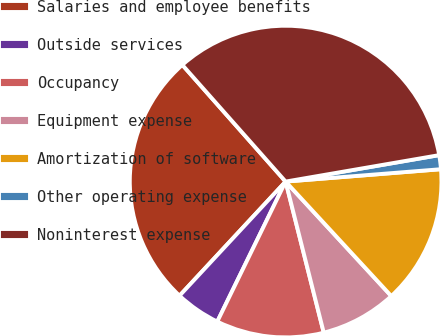Convert chart to OTSL. <chart><loc_0><loc_0><loc_500><loc_500><pie_chart><fcel>Salaries and employee benefits<fcel>Outside services<fcel>Occupancy<fcel>Equipment expense<fcel>Amortization of software<fcel>Other operating expense<fcel>Noninterest expense<nl><fcel>26.55%<fcel>4.69%<fcel>11.16%<fcel>7.93%<fcel>14.4%<fcel>1.45%<fcel>33.82%<nl></chart> 